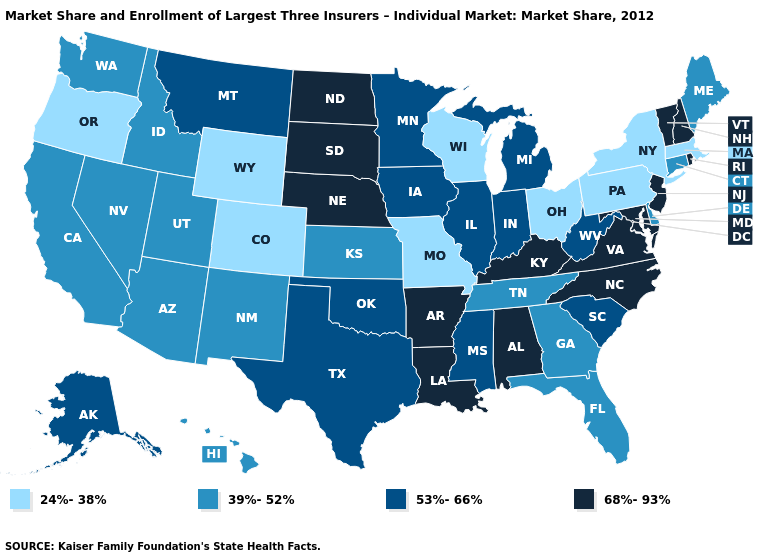What is the value of Wyoming?
Answer briefly. 24%-38%. Name the states that have a value in the range 24%-38%?
Short answer required. Colorado, Massachusetts, Missouri, New York, Ohio, Oregon, Pennsylvania, Wisconsin, Wyoming. Does Alabama have the highest value in the USA?
Keep it brief. Yes. Name the states that have a value in the range 39%-52%?
Answer briefly. Arizona, California, Connecticut, Delaware, Florida, Georgia, Hawaii, Idaho, Kansas, Maine, Nevada, New Mexico, Tennessee, Utah, Washington. Does Connecticut have the highest value in the Northeast?
Be succinct. No. Does New York have the lowest value in the USA?
Keep it brief. Yes. Name the states that have a value in the range 24%-38%?
Give a very brief answer. Colorado, Massachusetts, Missouri, New York, Ohio, Oregon, Pennsylvania, Wisconsin, Wyoming. Does Idaho have a higher value than Ohio?
Short answer required. Yes. What is the value of Nebraska?
Be succinct. 68%-93%. Does Maryland have the highest value in the USA?
Keep it brief. Yes. Name the states that have a value in the range 53%-66%?
Be succinct. Alaska, Illinois, Indiana, Iowa, Michigan, Minnesota, Mississippi, Montana, Oklahoma, South Carolina, Texas, West Virginia. Name the states that have a value in the range 24%-38%?
Concise answer only. Colorado, Massachusetts, Missouri, New York, Ohio, Oregon, Pennsylvania, Wisconsin, Wyoming. Which states have the lowest value in the West?
Concise answer only. Colorado, Oregon, Wyoming. Is the legend a continuous bar?
Write a very short answer. No. Name the states that have a value in the range 24%-38%?
Answer briefly. Colorado, Massachusetts, Missouri, New York, Ohio, Oregon, Pennsylvania, Wisconsin, Wyoming. 